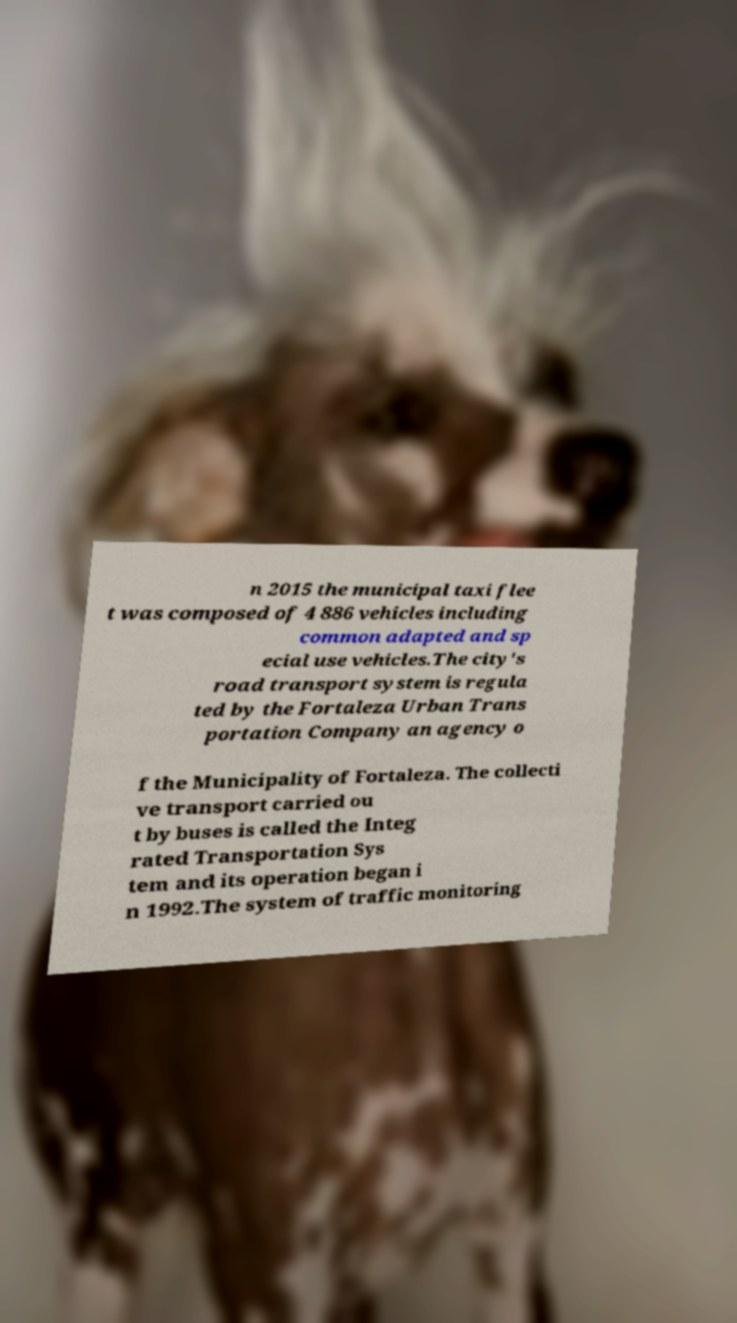Please identify and transcribe the text found in this image. n 2015 the municipal taxi flee t was composed of 4 886 vehicles including common adapted and sp ecial use vehicles.The city's road transport system is regula ted by the Fortaleza Urban Trans portation Company an agency o f the Municipality of Fortaleza. The collecti ve transport carried ou t by buses is called the Integ rated Transportation Sys tem and its operation began i n 1992.The system of traffic monitoring 